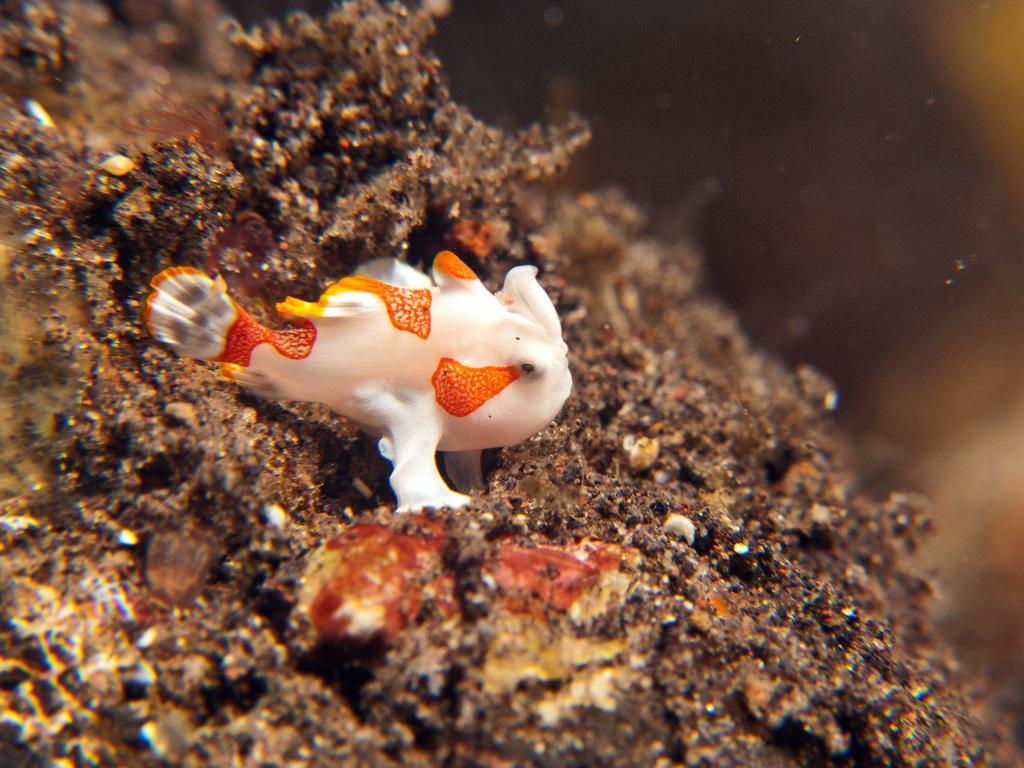Please provide a concise description of this image. In this picture I can see a fish and corals in the water. 